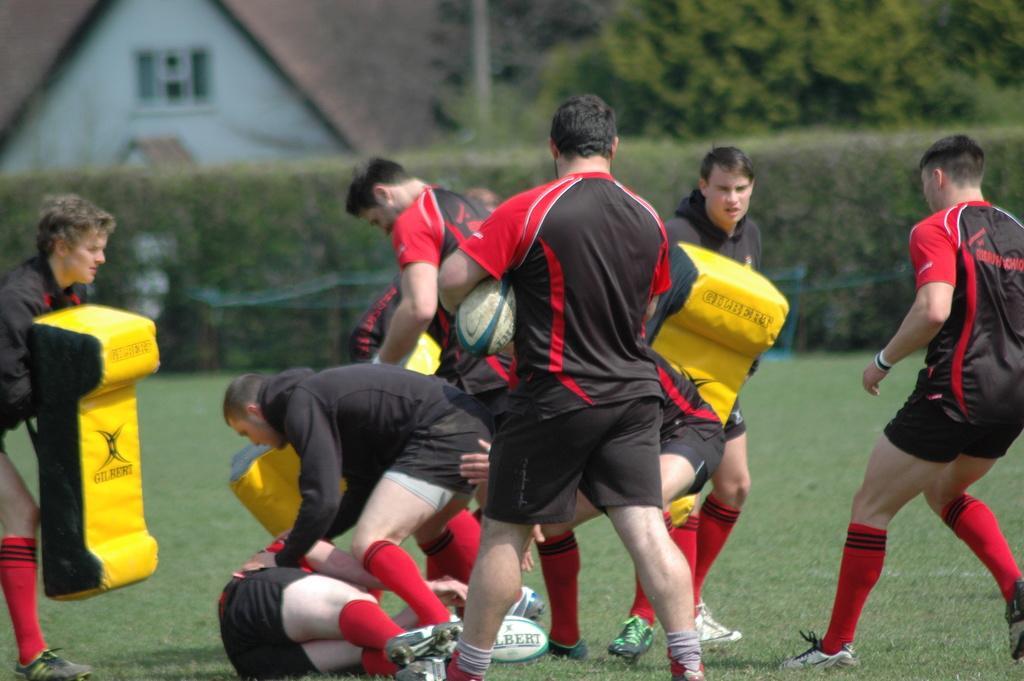Please provide a concise description of this image. In this image i can see a group of persons wearing similar dress playing a sport and at the background of the image there are trees and a house. 